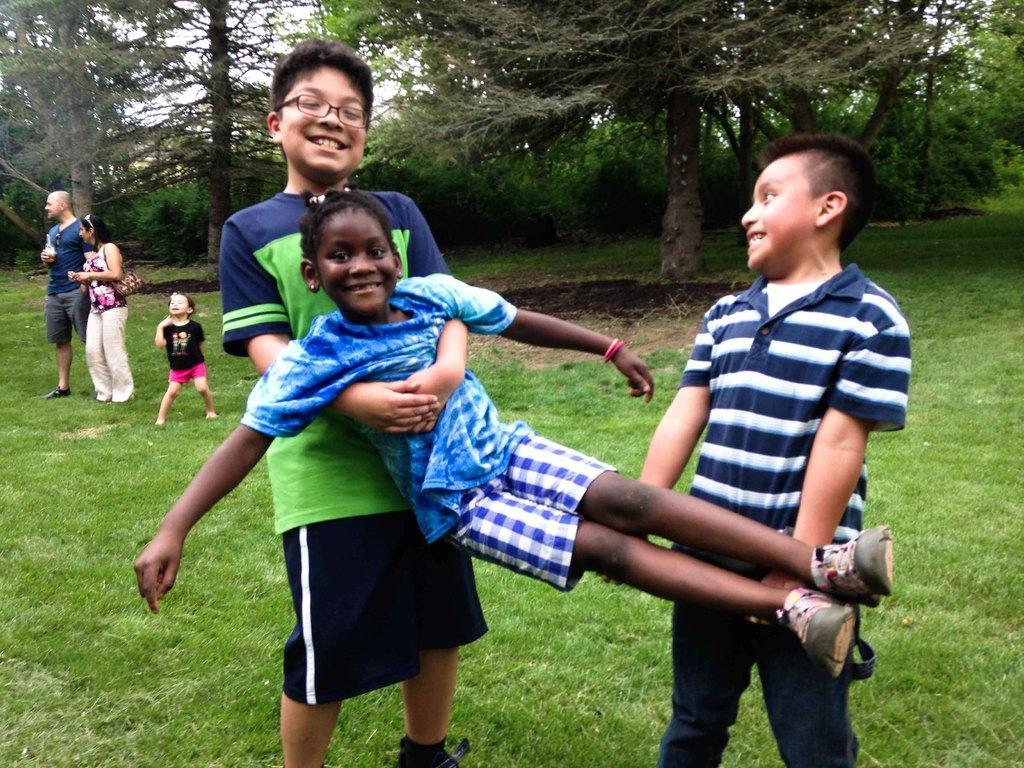In one or two sentences, can you explain what this image depicts? This picture is clicked outside. In the foreground we can see the two kids wearing t-shirts, smiling, standing and holding another kid. On the left we can see the two persons and a kid standing on the ground. The ground is covered with the green grass. In the background we can see the sky, trees and plants. 